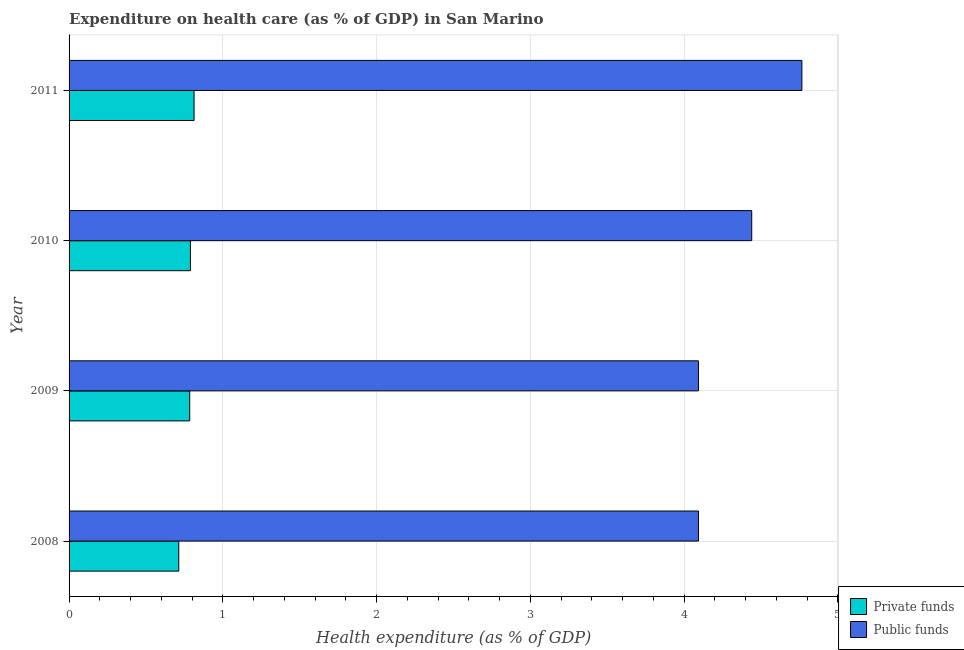How many different coloured bars are there?
Your answer should be compact. 2. How many groups of bars are there?
Keep it short and to the point. 4. Are the number of bars per tick equal to the number of legend labels?
Give a very brief answer. Yes. How many bars are there on the 4th tick from the top?
Provide a succinct answer. 2. What is the amount of private funds spent in healthcare in 2011?
Your response must be concise. 0.81. Across all years, what is the maximum amount of public funds spent in healthcare?
Keep it short and to the point. 4.77. Across all years, what is the minimum amount of private funds spent in healthcare?
Provide a succinct answer. 0.71. In which year was the amount of public funds spent in healthcare minimum?
Your response must be concise. 2009. What is the total amount of private funds spent in healthcare in the graph?
Provide a succinct answer. 3.1. What is the difference between the amount of private funds spent in healthcare in 2009 and that in 2011?
Provide a short and direct response. -0.03. What is the difference between the amount of public funds spent in healthcare in 2008 and the amount of private funds spent in healthcare in 2010?
Provide a short and direct response. 3.3. What is the average amount of private funds spent in healthcare per year?
Ensure brevity in your answer.  0.78. In the year 2008, what is the difference between the amount of private funds spent in healthcare and amount of public funds spent in healthcare?
Offer a terse response. -3.38. What is the ratio of the amount of public funds spent in healthcare in 2009 to that in 2011?
Offer a very short reply. 0.86. Is the difference between the amount of public funds spent in healthcare in 2010 and 2011 greater than the difference between the amount of private funds spent in healthcare in 2010 and 2011?
Provide a succinct answer. No. What is the difference between the highest and the second highest amount of private funds spent in healthcare?
Give a very brief answer. 0.02. What is the difference between the highest and the lowest amount of public funds spent in healthcare?
Ensure brevity in your answer.  0.67. Is the sum of the amount of private funds spent in healthcare in 2009 and 2010 greater than the maximum amount of public funds spent in healthcare across all years?
Ensure brevity in your answer.  No. What does the 2nd bar from the top in 2011 represents?
Your answer should be compact. Private funds. What does the 2nd bar from the bottom in 2011 represents?
Provide a succinct answer. Public funds. Are all the bars in the graph horizontal?
Your answer should be compact. Yes. How many years are there in the graph?
Keep it short and to the point. 4. What is the difference between two consecutive major ticks on the X-axis?
Ensure brevity in your answer.  1. Does the graph contain any zero values?
Provide a short and direct response. No. Does the graph contain grids?
Provide a short and direct response. Yes. Where does the legend appear in the graph?
Offer a terse response. Bottom right. How many legend labels are there?
Your answer should be very brief. 2. How are the legend labels stacked?
Ensure brevity in your answer.  Vertical. What is the title of the graph?
Your answer should be very brief. Expenditure on health care (as % of GDP) in San Marino. What is the label or title of the X-axis?
Your answer should be very brief. Health expenditure (as % of GDP). What is the label or title of the Y-axis?
Your answer should be very brief. Year. What is the Health expenditure (as % of GDP) of Private funds in 2008?
Your response must be concise. 0.71. What is the Health expenditure (as % of GDP) of Public funds in 2008?
Keep it short and to the point. 4.09. What is the Health expenditure (as % of GDP) of Private funds in 2009?
Provide a short and direct response. 0.78. What is the Health expenditure (as % of GDP) in Public funds in 2009?
Ensure brevity in your answer.  4.09. What is the Health expenditure (as % of GDP) of Private funds in 2010?
Your answer should be compact. 0.79. What is the Health expenditure (as % of GDP) of Public funds in 2010?
Provide a short and direct response. 4.44. What is the Health expenditure (as % of GDP) in Private funds in 2011?
Keep it short and to the point. 0.81. What is the Health expenditure (as % of GDP) of Public funds in 2011?
Offer a terse response. 4.77. Across all years, what is the maximum Health expenditure (as % of GDP) of Private funds?
Your answer should be very brief. 0.81. Across all years, what is the maximum Health expenditure (as % of GDP) of Public funds?
Offer a terse response. 4.77. Across all years, what is the minimum Health expenditure (as % of GDP) of Private funds?
Your answer should be compact. 0.71. Across all years, what is the minimum Health expenditure (as % of GDP) in Public funds?
Make the answer very short. 4.09. What is the total Health expenditure (as % of GDP) in Private funds in the graph?
Your answer should be compact. 3.1. What is the total Health expenditure (as % of GDP) in Public funds in the graph?
Provide a short and direct response. 17.39. What is the difference between the Health expenditure (as % of GDP) of Private funds in 2008 and that in 2009?
Keep it short and to the point. -0.07. What is the difference between the Health expenditure (as % of GDP) of Public funds in 2008 and that in 2009?
Keep it short and to the point. 0. What is the difference between the Health expenditure (as % of GDP) of Private funds in 2008 and that in 2010?
Keep it short and to the point. -0.08. What is the difference between the Health expenditure (as % of GDP) of Public funds in 2008 and that in 2010?
Make the answer very short. -0.35. What is the difference between the Health expenditure (as % of GDP) in Private funds in 2008 and that in 2011?
Your answer should be very brief. -0.1. What is the difference between the Health expenditure (as % of GDP) in Public funds in 2008 and that in 2011?
Your answer should be very brief. -0.67. What is the difference between the Health expenditure (as % of GDP) in Private funds in 2009 and that in 2010?
Offer a terse response. -0. What is the difference between the Health expenditure (as % of GDP) of Public funds in 2009 and that in 2010?
Offer a terse response. -0.35. What is the difference between the Health expenditure (as % of GDP) in Private funds in 2009 and that in 2011?
Provide a succinct answer. -0.03. What is the difference between the Health expenditure (as % of GDP) in Public funds in 2009 and that in 2011?
Provide a succinct answer. -0.67. What is the difference between the Health expenditure (as % of GDP) in Private funds in 2010 and that in 2011?
Your answer should be very brief. -0.02. What is the difference between the Health expenditure (as % of GDP) in Public funds in 2010 and that in 2011?
Your answer should be very brief. -0.33. What is the difference between the Health expenditure (as % of GDP) of Private funds in 2008 and the Health expenditure (as % of GDP) of Public funds in 2009?
Ensure brevity in your answer.  -3.38. What is the difference between the Health expenditure (as % of GDP) in Private funds in 2008 and the Health expenditure (as % of GDP) in Public funds in 2010?
Your answer should be very brief. -3.73. What is the difference between the Health expenditure (as % of GDP) in Private funds in 2008 and the Health expenditure (as % of GDP) in Public funds in 2011?
Ensure brevity in your answer.  -4.05. What is the difference between the Health expenditure (as % of GDP) in Private funds in 2009 and the Health expenditure (as % of GDP) in Public funds in 2010?
Your answer should be compact. -3.66. What is the difference between the Health expenditure (as % of GDP) of Private funds in 2009 and the Health expenditure (as % of GDP) of Public funds in 2011?
Provide a short and direct response. -3.98. What is the difference between the Health expenditure (as % of GDP) in Private funds in 2010 and the Health expenditure (as % of GDP) in Public funds in 2011?
Make the answer very short. -3.98. What is the average Health expenditure (as % of GDP) in Private funds per year?
Your answer should be compact. 0.78. What is the average Health expenditure (as % of GDP) in Public funds per year?
Your answer should be compact. 4.35. In the year 2008, what is the difference between the Health expenditure (as % of GDP) of Private funds and Health expenditure (as % of GDP) of Public funds?
Offer a terse response. -3.38. In the year 2009, what is the difference between the Health expenditure (as % of GDP) of Private funds and Health expenditure (as % of GDP) of Public funds?
Offer a terse response. -3.31. In the year 2010, what is the difference between the Health expenditure (as % of GDP) of Private funds and Health expenditure (as % of GDP) of Public funds?
Offer a terse response. -3.65. In the year 2011, what is the difference between the Health expenditure (as % of GDP) in Private funds and Health expenditure (as % of GDP) in Public funds?
Offer a terse response. -3.95. What is the ratio of the Health expenditure (as % of GDP) in Private funds in 2008 to that in 2009?
Keep it short and to the point. 0.91. What is the ratio of the Health expenditure (as % of GDP) in Public funds in 2008 to that in 2009?
Your answer should be compact. 1. What is the ratio of the Health expenditure (as % of GDP) in Private funds in 2008 to that in 2010?
Your response must be concise. 0.9. What is the ratio of the Health expenditure (as % of GDP) in Public funds in 2008 to that in 2010?
Give a very brief answer. 0.92. What is the ratio of the Health expenditure (as % of GDP) of Private funds in 2008 to that in 2011?
Keep it short and to the point. 0.88. What is the ratio of the Health expenditure (as % of GDP) of Public funds in 2008 to that in 2011?
Give a very brief answer. 0.86. What is the ratio of the Health expenditure (as % of GDP) of Public funds in 2009 to that in 2010?
Provide a succinct answer. 0.92. What is the ratio of the Health expenditure (as % of GDP) of Private funds in 2009 to that in 2011?
Your answer should be compact. 0.97. What is the ratio of the Health expenditure (as % of GDP) of Public funds in 2009 to that in 2011?
Ensure brevity in your answer.  0.86. What is the ratio of the Health expenditure (as % of GDP) in Private funds in 2010 to that in 2011?
Ensure brevity in your answer.  0.97. What is the ratio of the Health expenditure (as % of GDP) of Public funds in 2010 to that in 2011?
Your response must be concise. 0.93. What is the difference between the highest and the second highest Health expenditure (as % of GDP) of Private funds?
Provide a short and direct response. 0.02. What is the difference between the highest and the second highest Health expenditure (as % of GDP) of Public funds?
Your response must be concise. 0.33. What is the difference between the highest and the lowest Health expenditure (as % of GDP) of Private funds?
Your answer should be compact. 0.1. What is the difference between the highest and the lowest Health expenditure (as % of GDP) in Public funds?
Ensure brevity in your answer.  0.67. 